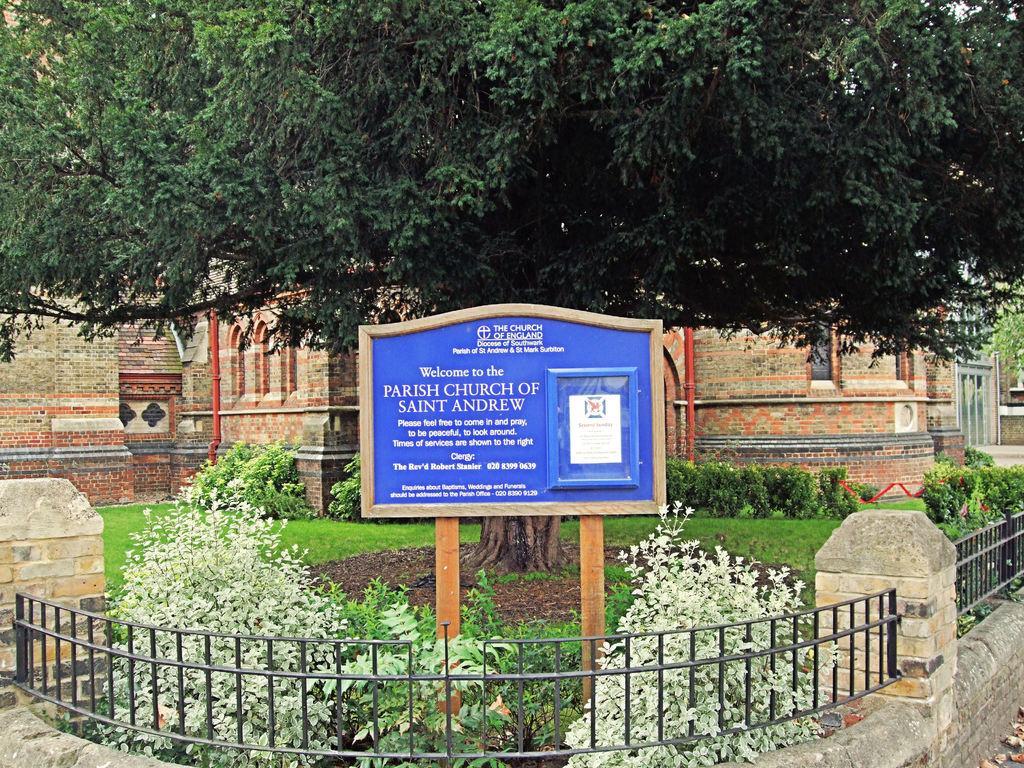In one or two sentences, can you explain what this image depicts? In this image I can see there is a building , in front of the building I can see tree, in front of the tree I can see a board , fence and plants 